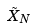<formula> <loc_0><loc_0><loc_500><loc_500>\tilde { X } _ { N }</formula> 